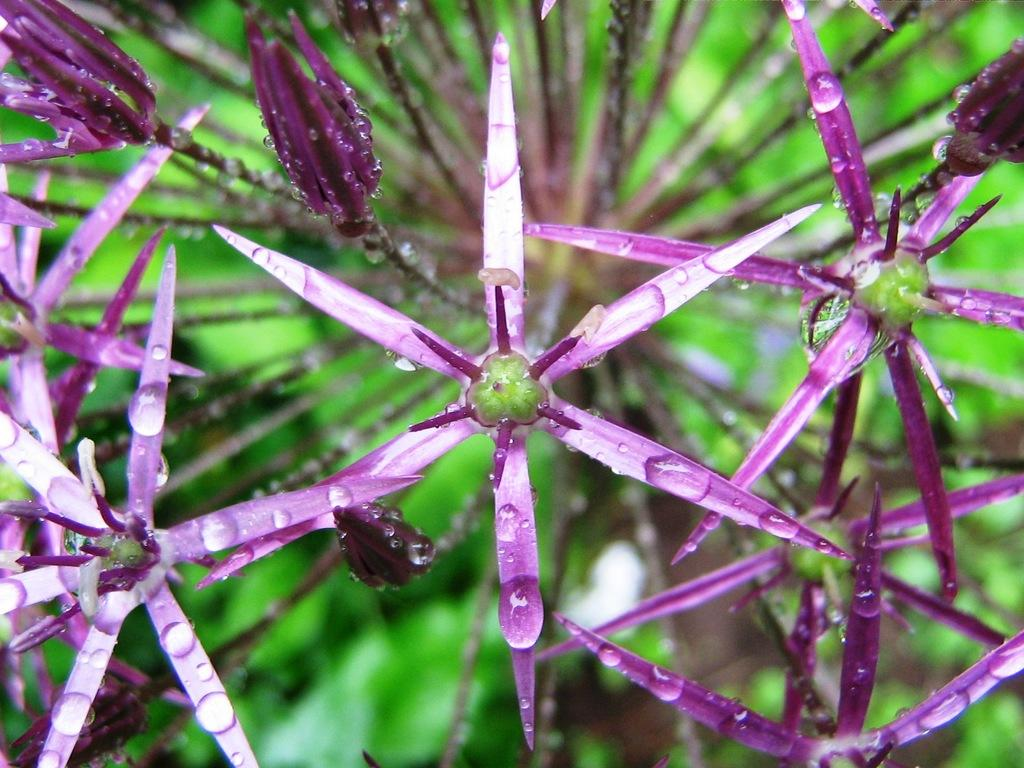What is the main subject of the image? The main subject of the image is a group of flowers. Where are the flowers located in the image? The flowers are on the stems of a plant. How many letters are visible in the image? There are no letters present in the image; it features a group of flowers on the stems of a plant. Can you see any cows in the image? There are no cows present in the image; it features a group of flowers on the stems of a plant. 